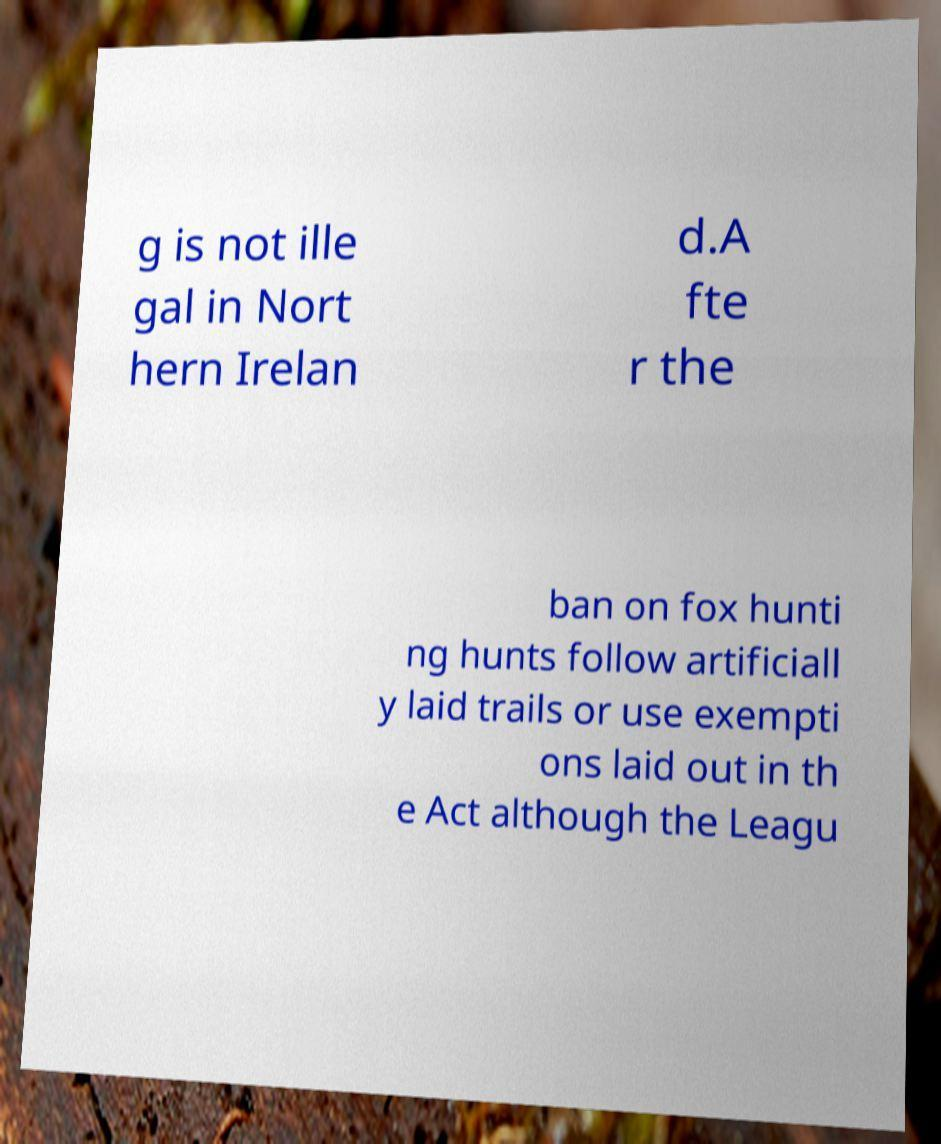Can you read and provide the text displayed in the image?This photo seems to have some interesting text. Can you extract and type it out for me? g is not ille gal in Nort hern Irelan d.A fte r the ban on fox hunti ng hunts follow artificiall y laid trails or use exempti ons laid out in th e Act although the Leagu 